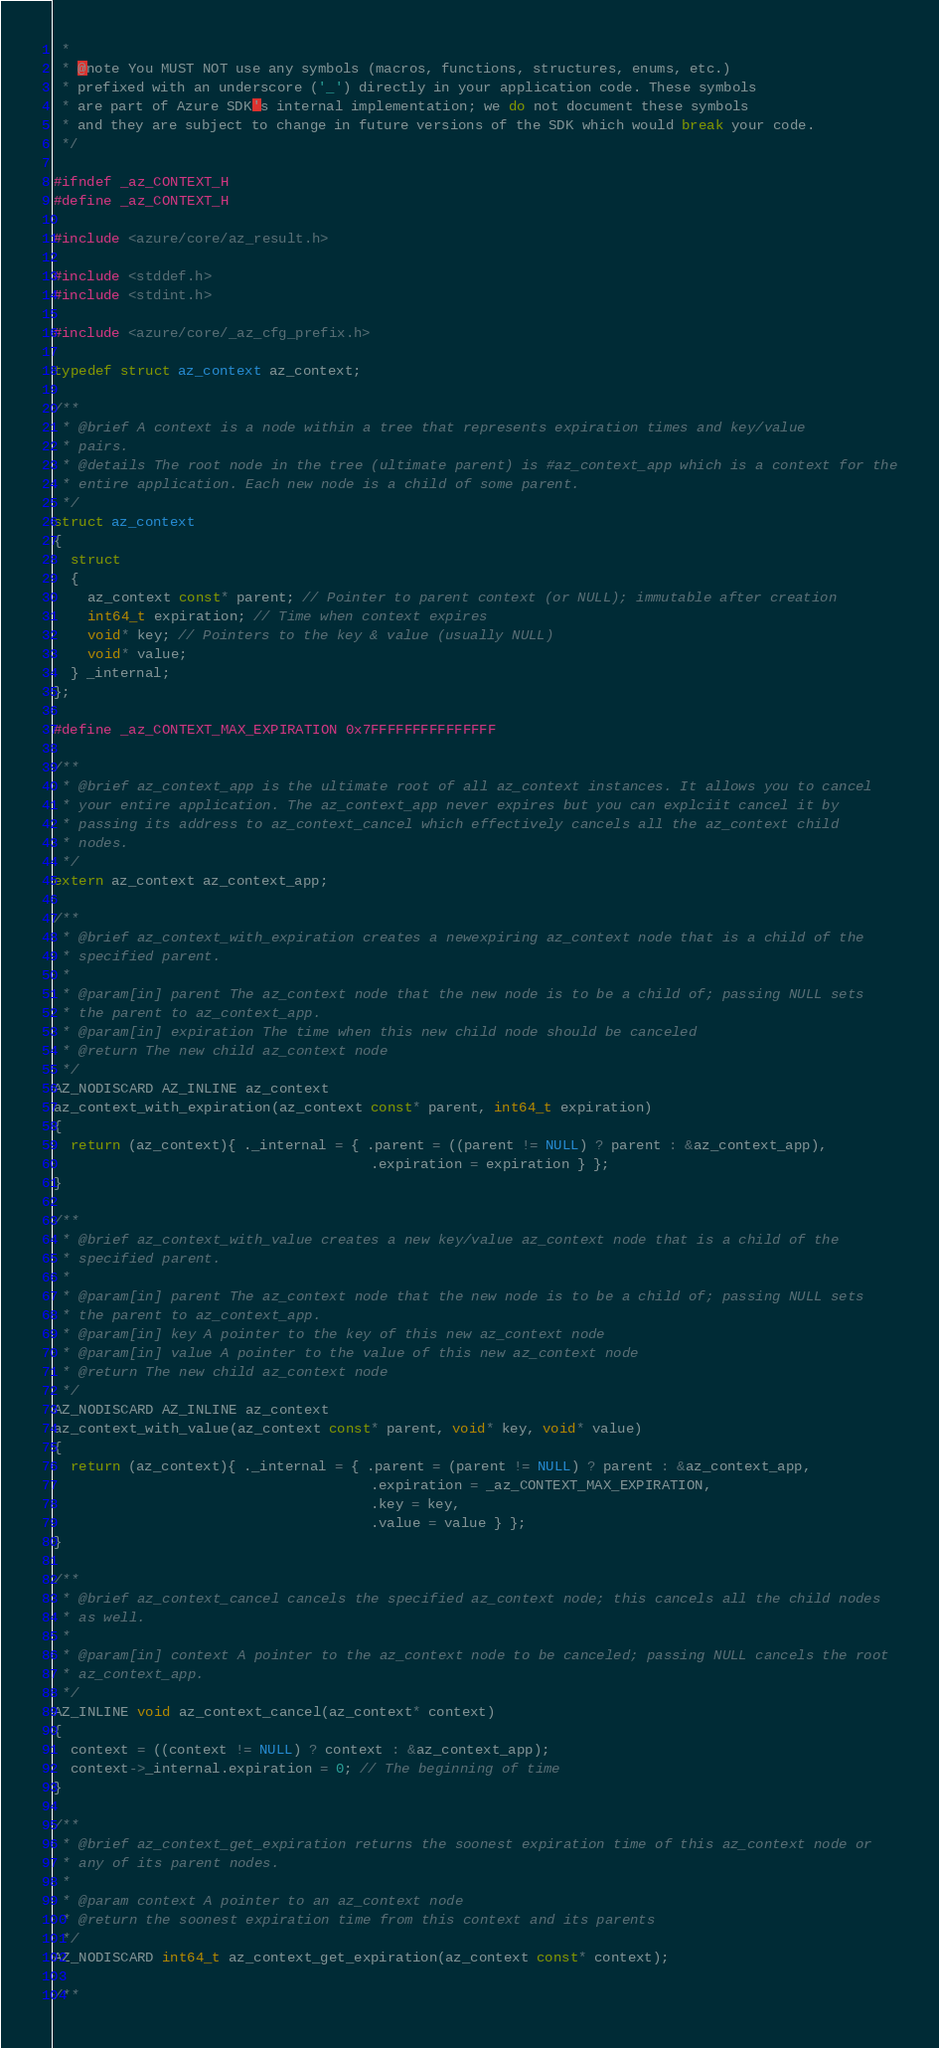Convert code to text. <code><loc_0><loc_0><loc_500><loc_500><_C_> *
 * @note You MUST NOT use any symbols (macros, functions, structures, enums, etc.)
 * prefixed with an underscore ('_') directly in your application code. These symbols
 * are part of Azure SDK's internal implementation; we do not document these symbols
 * and they are subject to change in future versions of the SDK which would break your code.
 */

#ifndef _az_CONTEXT_H
#define _az_CONTEXT_H

#include <azure/core/az_result.h>

#include <stddef.h>
#include <stdint.h>

#include <azure/core/_az_cfg_prefix.h>

typedef struct az_context az_context;

/**
 * @brief A context is a node within a tree that represents expiration times and key/value
 * pairs.
 * @details The root node in the tree (ultimate parent) is #az_context_app which is a context for the
 * entire application. Each new node is a child of some parent.
 */
struct az_context
{
  struct
  {
    az_context const* parent; // Pointer to parent context (or NULL); immutable after creation
    int64_t expiration; // Time when context expires
    void* key; // Pointers to the key & value (usually NULL)
    void* value;
  } _internal;
};

#define _az_CONTEXT_MAX_EXPIRATION 0x7FFFFFFFFFFFFFFF

/**
 * @brief az_context_app is the ultimate root of all az_context instances. It allows you to cancel
 * your entire application. The az_context_app never expires but you can explciit cancel it by
 * passing its address to az_context_cancel which effectively cancels all the az_context child
 * nodes.
 */
extern az_context az_context_app;

/**
 * @brief az_context_with_expiration creates a newexpiring az_context node that is a child of the
 * specified parent.
 *
 * @param[in] parent The az_context node that the new node is to be a child of; passing NULL sets
 * the parent to az_context_app.
 * @param[in] expiration The time when this new child node should be canceled
 * @return The new child az_context node
 */
AZ_NODISCARD AZ_INLINE az_context
az_context_with_expiration(az_context const* parent, int64_t expiration)
{
  return (az_context){ ._internal = { .parent = ((parent != NULL) ? parent : &az_context_app),
                                      .expiration = expiration } };
}

/**
 * @brief az_context_with_value creates a new key/value az_context node that is a child of the
 * specified parent.
 *
 * @param[in] parent The az_context node that the new node is to be a child of; passing NULL sets
 * the parent to az_context_app.
 * @param[in] key A pointer to the key of this new az_context node
 * @param[in] value A pointer to the value of this new az_context node
 * @return The new child az_context node
 */
AZ_NODISCARD AZ_INLINE az_context
az_context_with_value(az_context const* parent, void* key, void* value)
{
  return (az_context){ ._internal = { .parent = (parent != NULL) ? parent : &az_context_app,
                                      .expiration = _az_CONTEXT_MAX_EXPIRATION,
                                      .key = key,
                                      .value = value } };
}

/**
 * @brief az_context_cancel cancels the specified az_context node; this cancels all the child nodes
 * as well.
 *
 * @param[in] context A pointer to the az_context node to be canceled; passing NULL cancels the root
 * az_context_app.
 */
AZ_INLINE void az_context_cancel(az_context* context)
{
  context = ((context != NULL) ? context : &az_context_app);
  context->_internal.expiration = 0; // The beginning of time
}

/**
 * @brief az_context_get_expiration returns the soonest expiration time of this az_context node or
 * any of its parent nodes.
 *
 * @param context A pointer to an az_context node
 * @return the soonest expiration time from this context and its parents
 */
AZ_NODISCARD int64_t az_context_get_expiration(az_context const* context);

/**</code> 